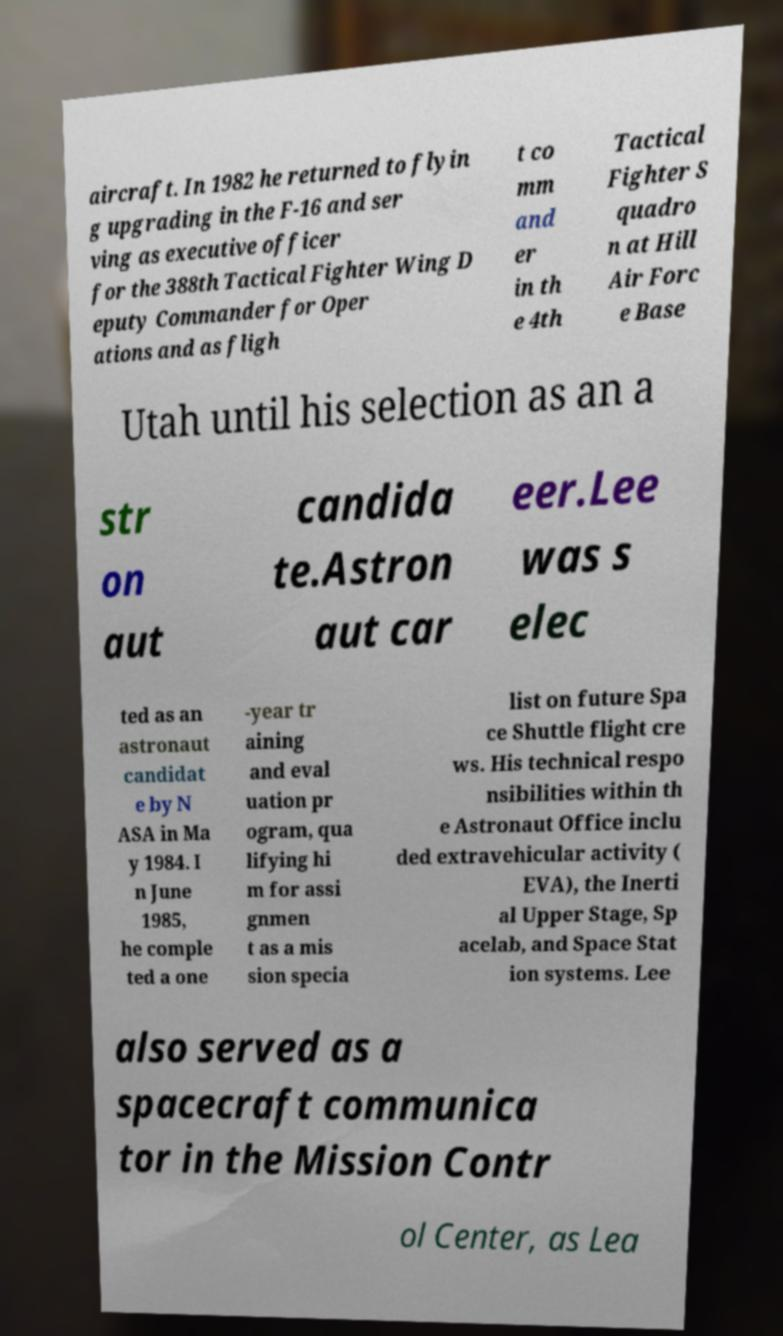There's text embedded in this image that I need extracted. Can you transcribe it verbatim? aircraft. In 1982 he returned to flyin g upgrading in the F-16 and ser ving as executive officer for the 388th Tactical Fighter Wing D eputy Commander for Oper ations and as fligh t co mm and er in th e 4th Tactical Fighter S quadro n at Hill Air Forc e Base Utah until his selection as an a str on aut candida te.Astron aut car eer.Lee was s elec ted as an astronaut candidat e by N ASA in Ma y 1984. I n June 1985, he comple ted a one -year tr aining and eval uation pr ogram, qua lifying hi m for assi gnmen t as a mis sion specia list on future Spa ce Shuttle flight cre ws. His technical respo nsibilities within th e Astronaut Office inclu ded extravehicular activity ( EVA), the Inerti al Upper Stage, Sp acelab, and Space Stat ion systems. Lee also served as a spacecraft communica tor in the Mission Contr ol Center, as Lea 